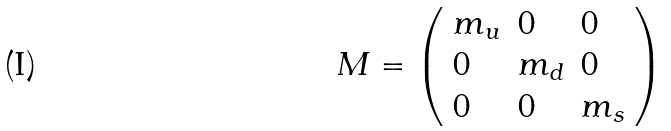<formula> <loc_0><loc_0><loc_500><loc_500>M = \left ( \begin{array} { l l l } { { m _ { u } } } & { 0 } & { 0 } \\ { 0 } & { { m _ { d } } } & { 0 } \\ { 0 } & { 0 } & { { m _ { s } } } \end{array} \right )</formula> 